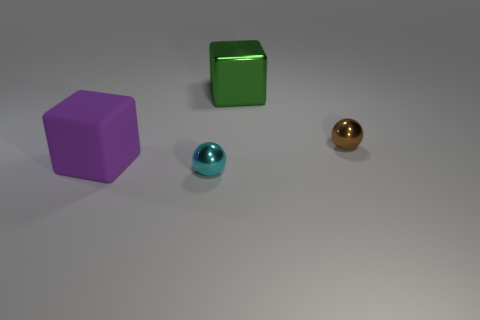There is a big thing on the right side of the small shiny object that is left of the big object that is on the right side of the purple thing; what is its material?
Ensure brevity in your answer.  Metal. How many small objects are green metal cylinders or metallic spheres?
Your answer should be very brief. 2. What number of other things are there of the same size as the green shiny thing?
Ensure brevity in your answer.  1. There is a tiny shiny thing to the left of the large metal block; is it the same shape as the large green object?
Offer a very short reply. No. There is another large rubber thing that is the same shape as the large green object; what color is it?
Your answer should be very brief. Purple. Are there any other things that are the same shape as the purple matte thing?
Provide a short and direct response. Yes. Is the number of large green things that are in front of the tiny cyan ball the same as the number of large gray rubber spheres?
Ensure brevity in your answer.  Yes. How many objects are both in front of the small brown metallic object and right of the large matte cube?
Your answer should be compact. 1. There is another purple thing that is the same shape as the large metal object; what size is it?
Offer a very short reply. Large. What number of cyan things have the same material as the big green thing?
Provide a succinct answer. 1. 